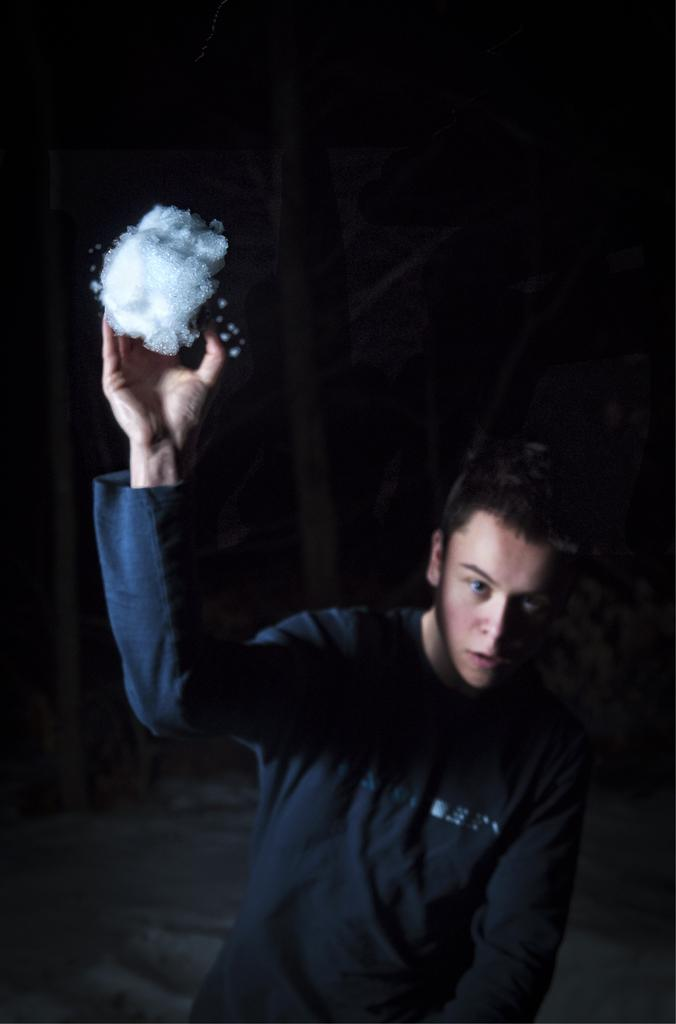What is the main subject of the picture? The main subject of the picture is a boy. Can you describe what the boy is wearing? The boy is wearing a t-shirt. What is the boy holding in his hand? The boy is holding an object in his hand. How many kittens are sitting on the boy's lap in the image? There are no kittens present in the image. What type of hen can be seen in the background of the image? There is no hen present in the image. 